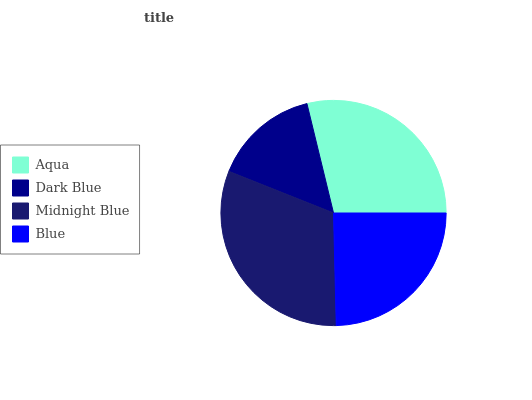Is Dark Blue the minimum?
Answer yes or no. Yes. Is Midnight Blue the maximum?
Answer yes or no. Yes. Is Midnight Blue the minimum?
Answer yes or no. No. Is Dark Blue the maximum?
Answer yes or no. No. Is Midnight Blue greater than Dark Blue?
Answer yes or no. Yes. Is Dark Blue less than Midnight Blue?
Answer yes or no. Yes. Is Dark Blue greater than Midnight Blue?
Answer yes or no. No. Is Midnight Blue less than Dark Blue?
Answer yes or no. No. Is Aqua the high median?
Answer yes or no. Yes. Is Blue the low median?
Answer yes or no. Yes. Is Blue the high median?
Answer yes or no. No. Is Aqua the low median?
Answer yes or no. No. 